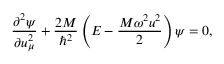<formula> <loc_0><loc_0><loc_500><loc_500>\frac { { \partial } ^ { 2 } \psi } { \partial u _ { \mu } ^ { 2 } } + \frac { 2 M } { \hbar { ^ } { 2 } } \left ( E - \frac { M \omega ^ { 2 } u ^ { 2 } } { 2 } \right ) \psi = 0 ,</formula> 